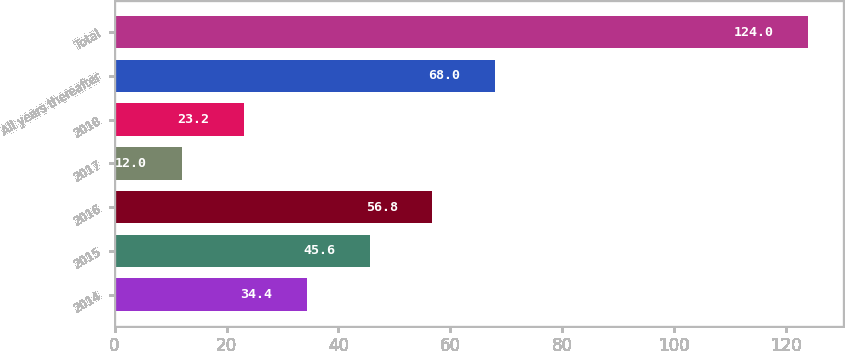<chart> <loc_0><loc_0><loc_500><loc_500><bar_chart><fcel>2014<fcel>2015<fcel>2016<fcel>2017<fcel>2018<fcel>All years thereafter<fcel>Total<nl><fcel>34.4<fcel>45.6<fcel>56.8<fcel>12<fcel>23.2<fcel>68<fcel>124<nl></chart> 